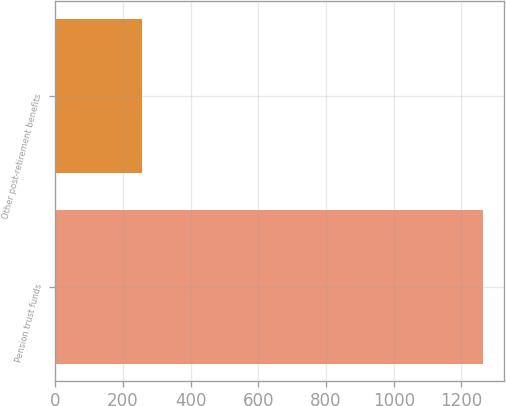Convert chart to OTSL. <chart><loc_0><loc_0><loc_500><loc_500><bar_chart><fcel>Pension trust funds<fcel>Other post-retirement benefits<nl><fcel>1262.5<fcel>255.4<nl></chart> 